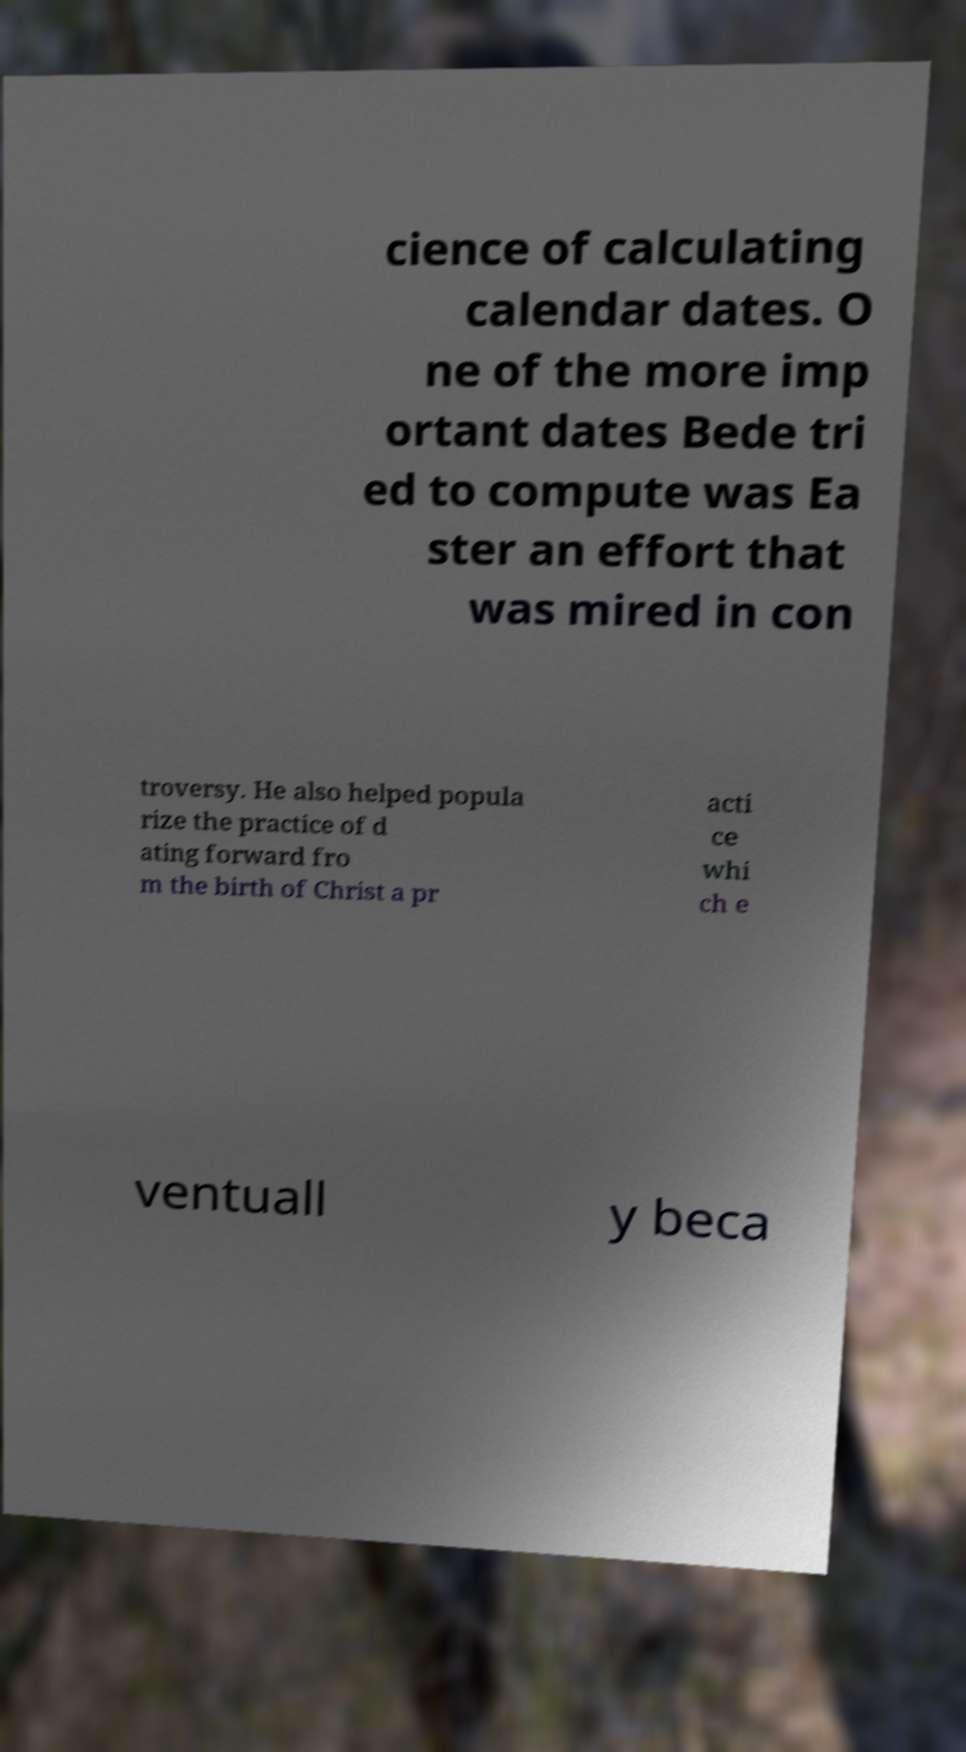Can you accurately transcribe the text from the provided image for me? cience of calculating calendar dates. O ne of the more imp ortant dates Bede tri ed to compute was Ea ster an effort that was mired in con troversy. He also helped popula rize the practice of d ating forward fro m the birth of Christ a pr acti ce whi ch e ventuall y beca 